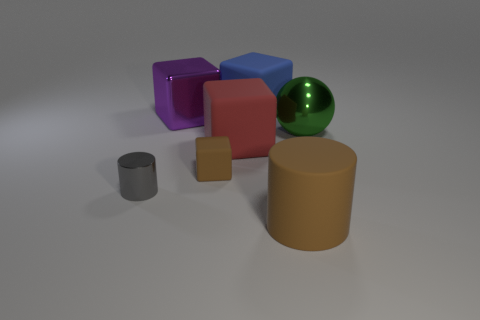What number of small gray objects have the same shape as the red object?
Provide a succinct answer. 0. The tiny brown rubber thing has what shape?
Offer a terse response. Cube. Is the number of gray spheres less than the number of small brown objects?
Ensure brevity in your answer.  Yes. There is a tiny brown object that is the same shape as the purple shiny thing; what material is it?
Your answer should be compact. Rubber. Are there more tiny blue metallic objects than large metal balls?
Provide a short and direct response. No. How many other things are there of the same color as the tiny metallic object?
Ensure brevity in your answer.  0. Is the purple cube made of the same material as the large cube in front of the big green metal sphere?
Offer a terse response. No. How many tiny brown things are on the right side of the cylinder that is right of the object that is behind the large metallic cube?
Your answer should be compact. 0. Is the number of big cylinders to the right of the big green ball less than the number of green shiny spheres that are behind the small cylinder?
Keep it short and to the point. Yes. What number of other objects are there of the same material as the large purple block?
Provide a short and direct response. 2. 